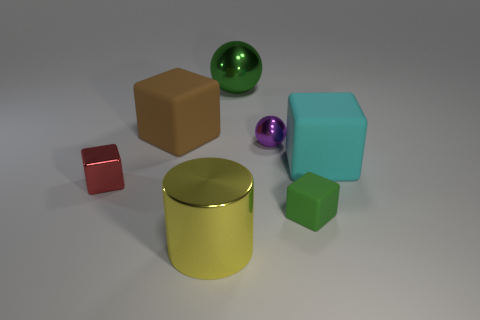Add 2 big brown things. How many objects exist? 9 Subtract all spheres. How many objects are left? 5 Subtract 1 red blocks. How many objects are left? 6 Subtract all small cyan objects. Subtract all yellow cylinders. How many objects are left? 6 Add 2 cylinders. How many cylinders are left? 3 Add 3 cyan matte cubes. How many cyan matte cubes exist? 4 